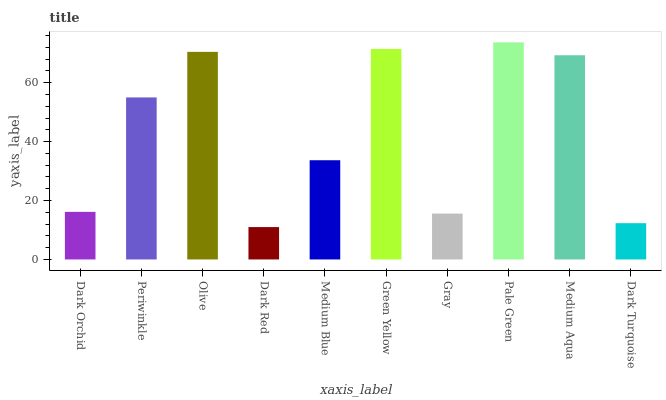Is Dark Red the minimum?
Answer yes or no. Yes. Is Pale Green the maximum?
Answer yes or no. Yes. Is Periwinkle the minimum?
Answer yes or no. No. Is Periwinkle the maximum?
Answer yes or no. No. Is Periwinkle greater than Dark Orchid?
Answer yes or no. Yes. Is Dark Orchid less than Periwinkle?
Answer yes or no. Yes. Is Dark Orchid greater than Periwinkle?
Answer yes or no. No. Is Periwinkle less than Dark Orchid?
Answer yes or no. No. Is Periwinkle the high median?
Answer yes or no. Yes. Is Medium Blue the low median?
Answer yes or no. Yes. Is Medium Blue the high median?
Answer yes or no. No. Is Dark Orchid the low median?
Answer yes or no. No. 